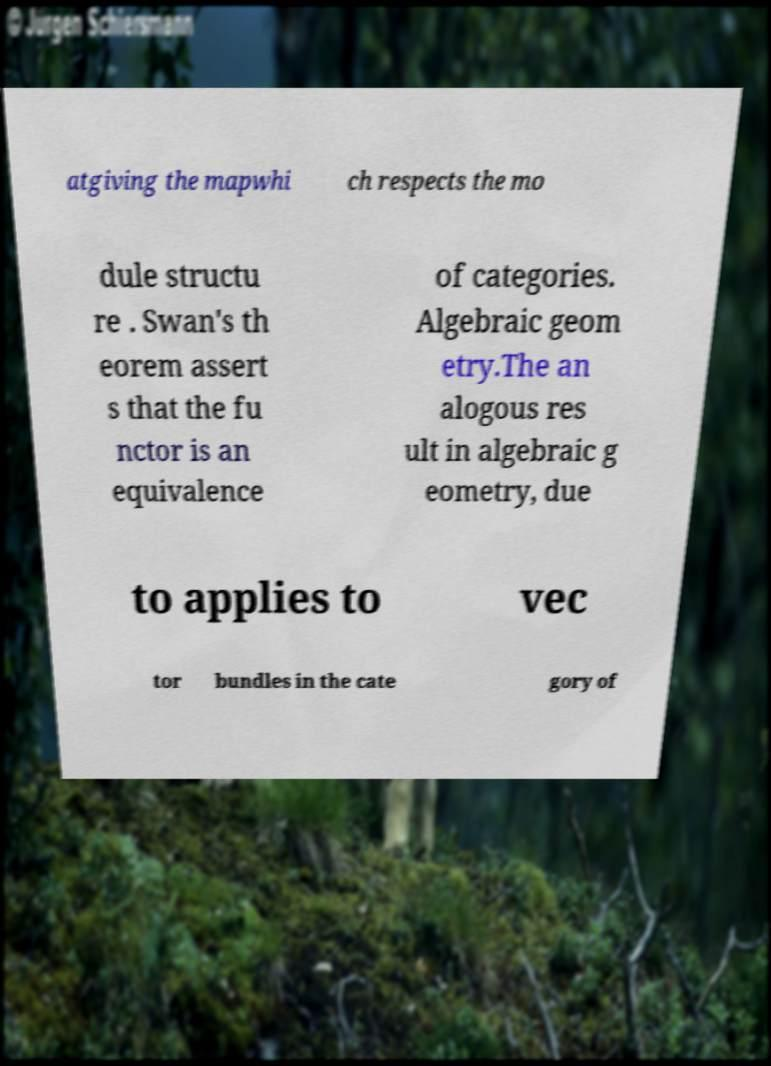What messages or text are displayed in this image? I need them in a readable, typed format. atgiving the mapwhi ch respects the mo dule structu re . Swan's th eorem assert s that the fu nctor is an equivalence of categories. Algebraic geom etry.The an alogous res ult in algebraic g eometry, due to applies to vec tor bundles in the cate gory of 